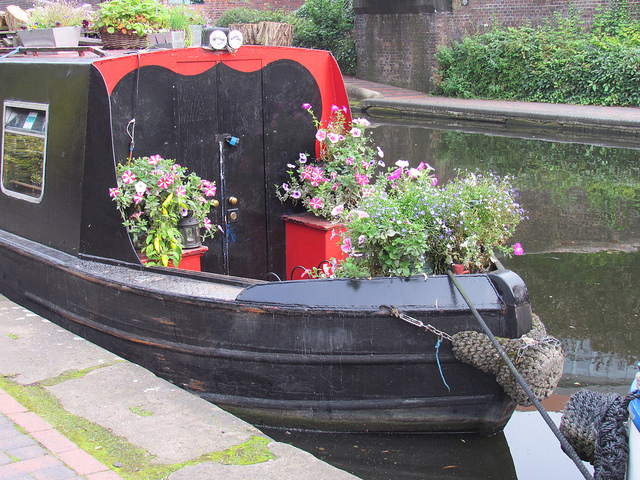<image>Are there any people on the boat? I don't know if there are any people on the boat. Are there any people on the boat? I don't know if there are any people on the boat. It seems like there are no people on the boat. 